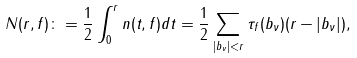Convert formula to latex. <formula><loc_0><loc_0><loc_500><loc_500>N ( r , f ) \colon = \frac { 1 } { 2 } \int _ { 0 } ^ { r } n ( t , f ) d t = \frac { 1 } { 2 } \sum _ { | b _ { \nu } | < r } \tau _ { f } ( b _ { \nu } ) ( r - | b _ { \nu } | ) ,</formula> 